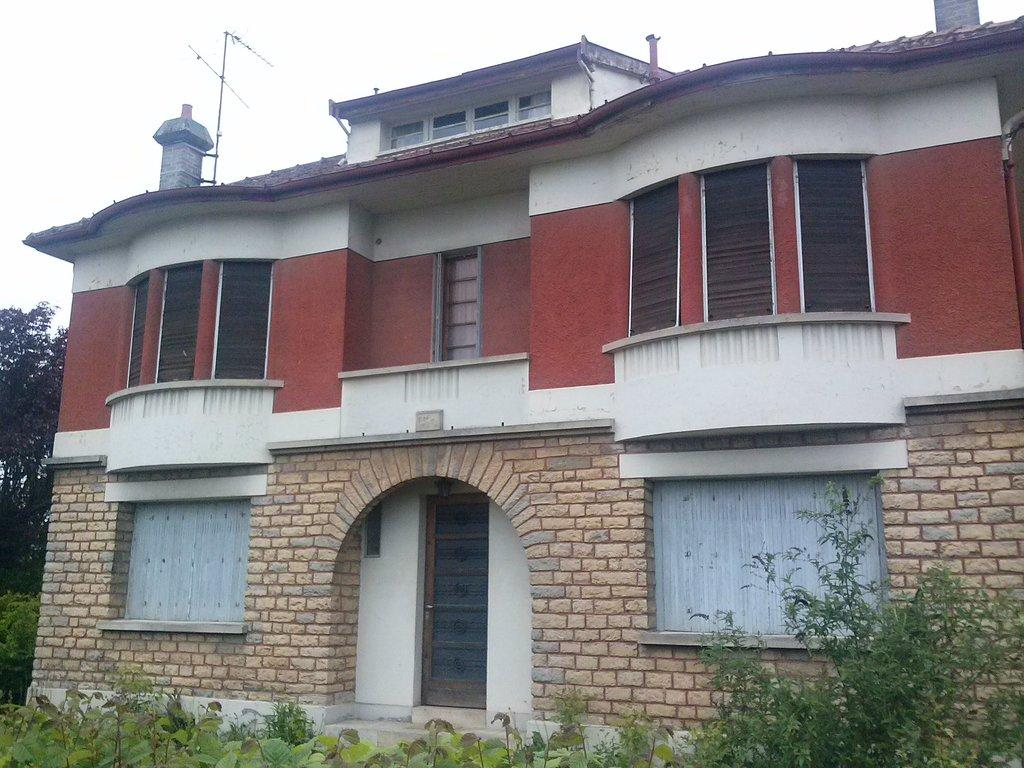What type of structure is present in the image? There is a building in the image. What other natural elements can be seen in the image? There is a tree and plants in the image. What part of the natural environment is visible in the image? The sky is visible in the image. What type of game is being played in the image? There is no game being played in the image; it features a building, a tree, plants, and the sky. Can you tell me how many tickets are visible in the image? There are no tickets present in the image. 